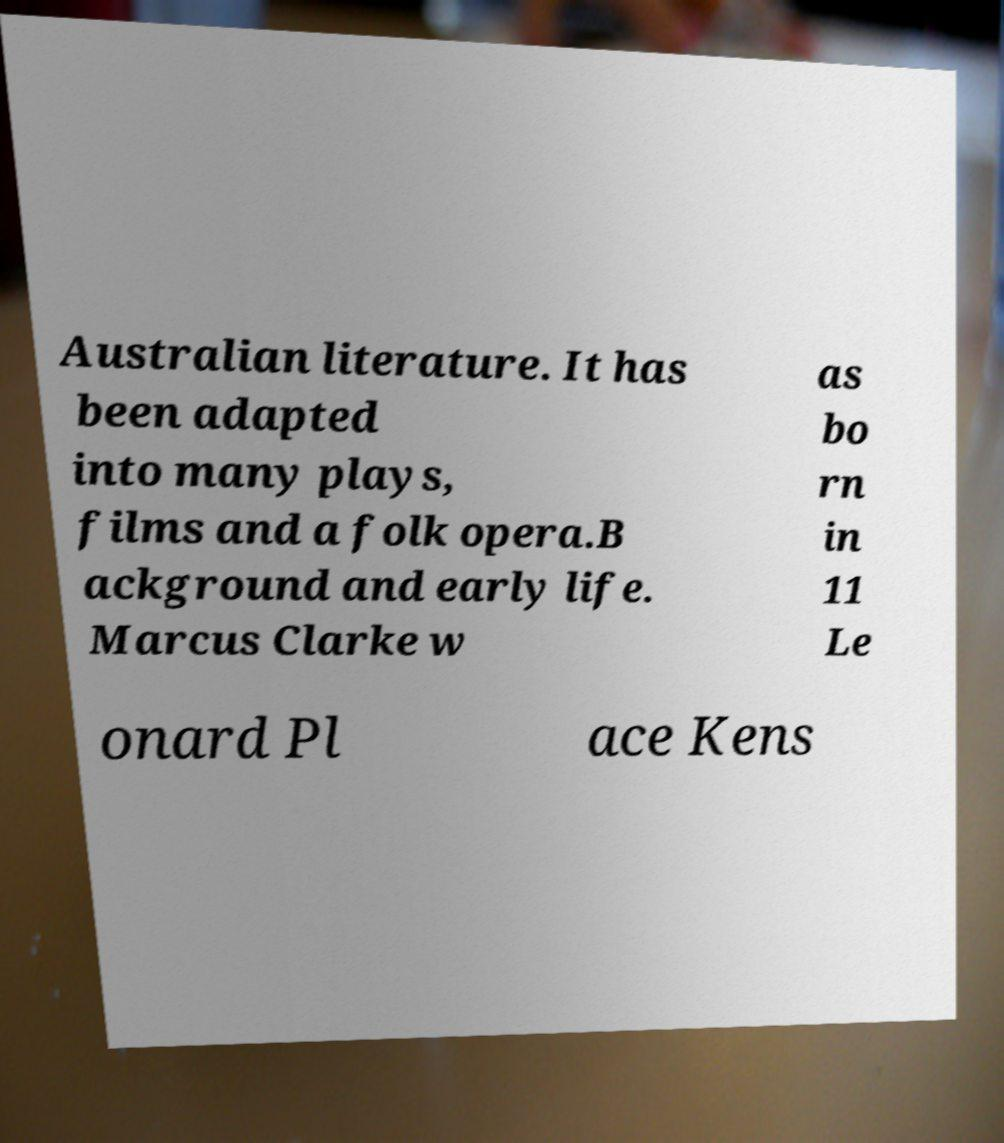I need the written content from this picture converted into text. Can you do that? Australian literature. It has been adapted into many plays, films and a folk opera.B ackground and early life. Marcus Clarke w as bo rn in 11 Le onard Pl ace Kens 